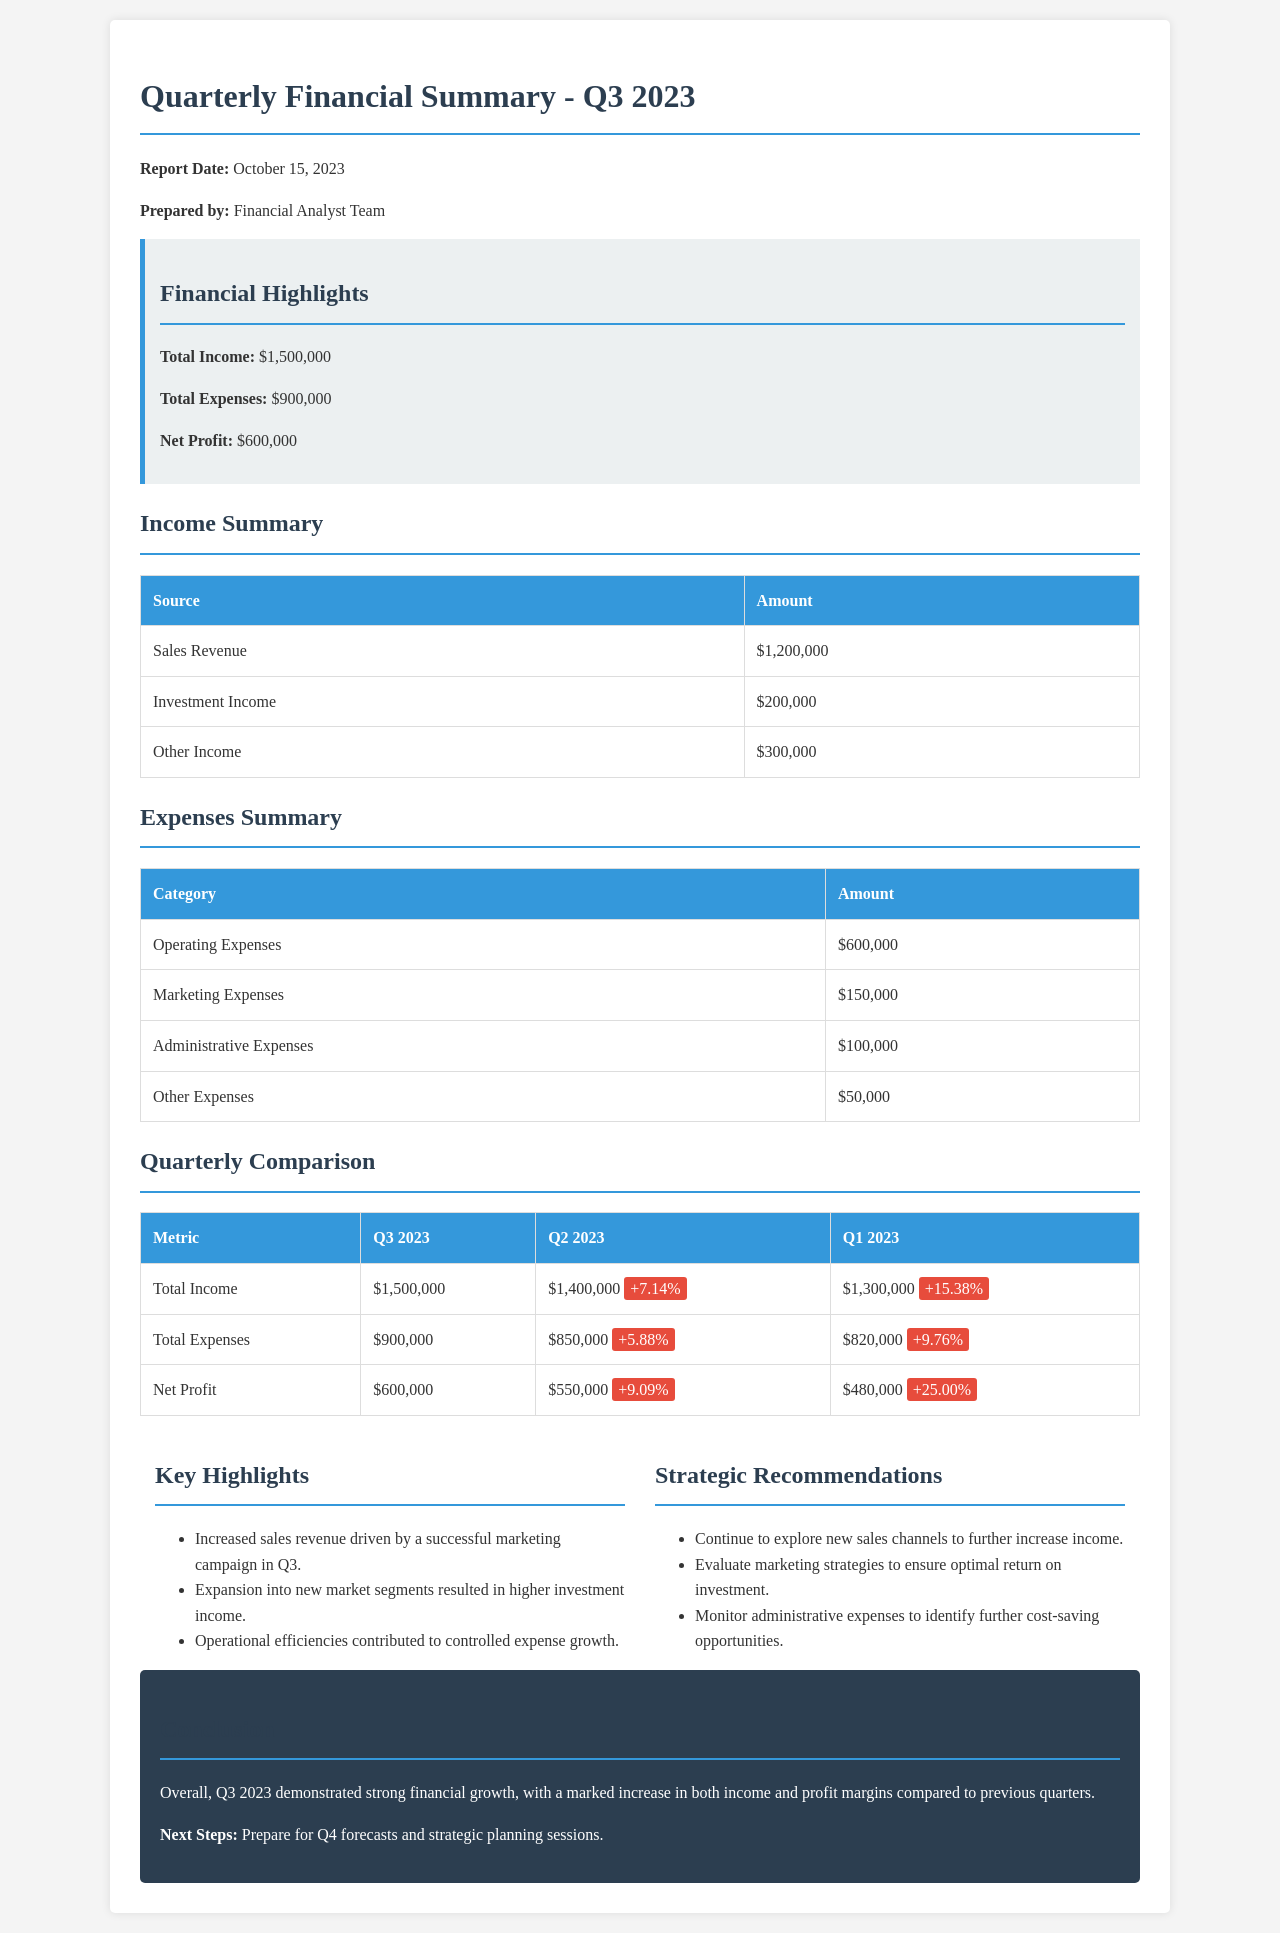What is the total income for Q3 2023? The total income for Q3 2023 is provided in the financial highlights section of the document.
Answer: $1,500,000 What are the total expenses for Q3 2023? The total expenses for Q3 2023 can be found in the financial highlights section of the document.
Answer: $900,000 What is the net profit for Q3 2023? The net profit figure is listed in the financial highlights section, showing the total profit after expenses.
Answer: $600,000 How much did sales revenue contribute to total income? The income summary section illustrates that sales revenue is a source of income that contributes to total income.
Answer: $1,200,000 What was the percentage increase in total income from Q2 2023 to Q3 2023? The quarterly comparison table indicates the percentage difference between Q2 and Q3 total income.
Answer: +7.14% Which expense category had the highest amount in Q3 2023? The expenses summary section lists the categories with their respective amounts, identifying the highest one.
Answer: Operating Expenses What is the date of the report? The report date is mentioned at the beginning of the document.
Answer: October 15, 2023 What strategy is recommended for exploring new sales channels? The strategic recommendations section outlines suggestions for future financial improvement, specifically mentioning sales channels.
Answer: Continue to explore new sales channels What was the primary driver behind increased sales revenue? The key highlights section explains the reasons for financial performance, particularly highlighting marketing campaigns.
Answer: Successful marketing campaign in Q3 What key fiscal metric showed the highest percentage increase in Q1 2023 compared to Q2 2023? The quarterly comparison table presents metrics with their percentage changes, aiding the identification of the largest increase.
Answer: Net Profit (+25.00%) 